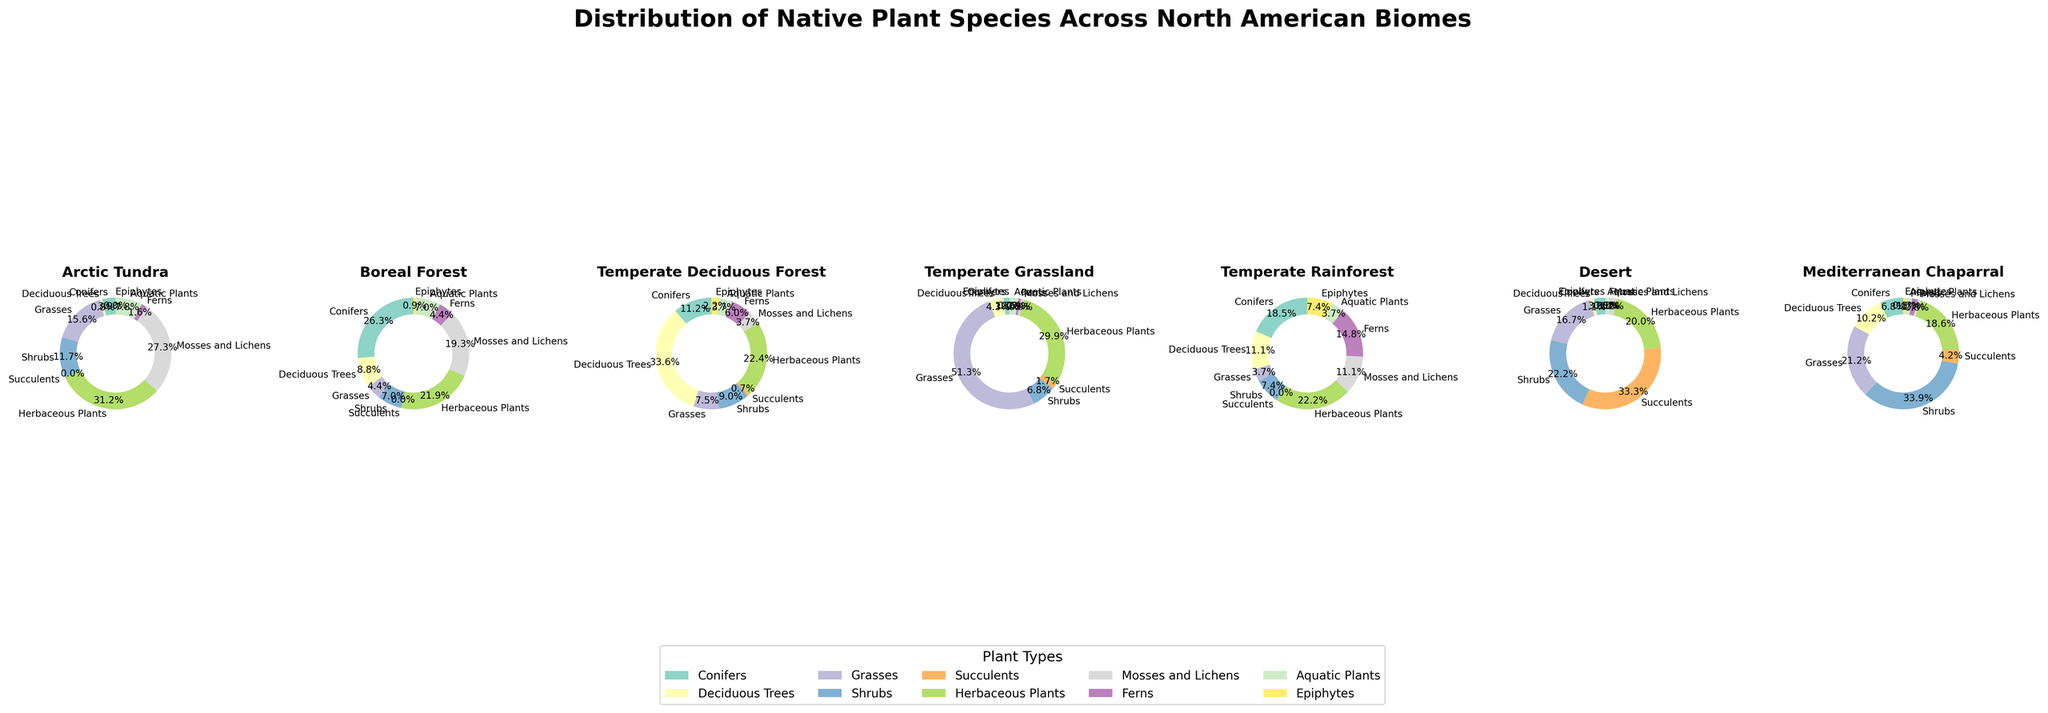What biome has the highest proportion of conifers? To find the biome with the highest proportion of conifers, look at each pie chart and identify the segment labeled "Conifers." The largest segment represents the highest proportion. The Boreal Forest pie chart shows the largest segment for conifers, thus it has the highest proportion.
Answer: Boreal Forest Which two biomes have the most similar proportions of grasses? Examine the pie charts for each biome and look at the segment labeled "Grasses". The biomes with similar segment sizes for grasses are Temperate Grassland and Mediterranean Chaparral, since they appear relatively close in size.
Answer: Temperate Grassland, Mediterranean Chaparral What is the difference in the proportion of herbaceous plants between the Desert and Temperate Rainforest biomes? Check the pie charts for the segments marked "Herbaceous Plants". The segment is larger in Temperate Rainforest compared to Desert. With Temperate Rainforest having about 30% and Desert having about 18%, the difference is 30% - 18% = 12%.
Answer: 12% Which plant type is very prevalent in the Arctic Tundra but not common in the Desert? Look at the pie charts for Arctic Tundra and Desert. The large segment in Arctic Tundra for "Mosses and Lichens" stands out compared to the small segment in Desert.
Answer: Mosses and Lichens Is the proportion of aquatic plants higher in Mediterranean Chaparral or Boreal Forest? Find the pie chart segments labeled "Aquatic Plants" for both Mediterranean Chaparral and Boreal Forest. The segment in Boreal Forest appears larger than the one in Mediterranean Chaparral.
Answer: Boreal Forest Calculate the average proportion of succulents in Temperate Grassland, Temperate Rainforest, and Mediterranean Chaparral. Find the segments labeled "Succulents" in the pie charts for the three biomes. The proportions are 2% in Temperate Grassland, 0% in Temperate Rainforest, and 5% in Mediterranean Chaparral. The average is (2+0+5)/3 = 7/3 ≈ 2.33%.
Answer: 2.33% Which biome has the smallest proportion of deciduous trees? Compare the segments labeled "Deciduous Trees" across all biomes. The smallest segment is in the Desert biome.
Answer: Desert What is the combined proportion of ferns in Temperate Deciduous Forest and Mediterranean Chaparral? Look at the pie charts for "Ferns" segments. Temperate Deciduous Forest has about 8% and Mediterranean Chaparral has about 2%, so their combined proportion is 8% + 2% = 10%.
Answer: 10% 